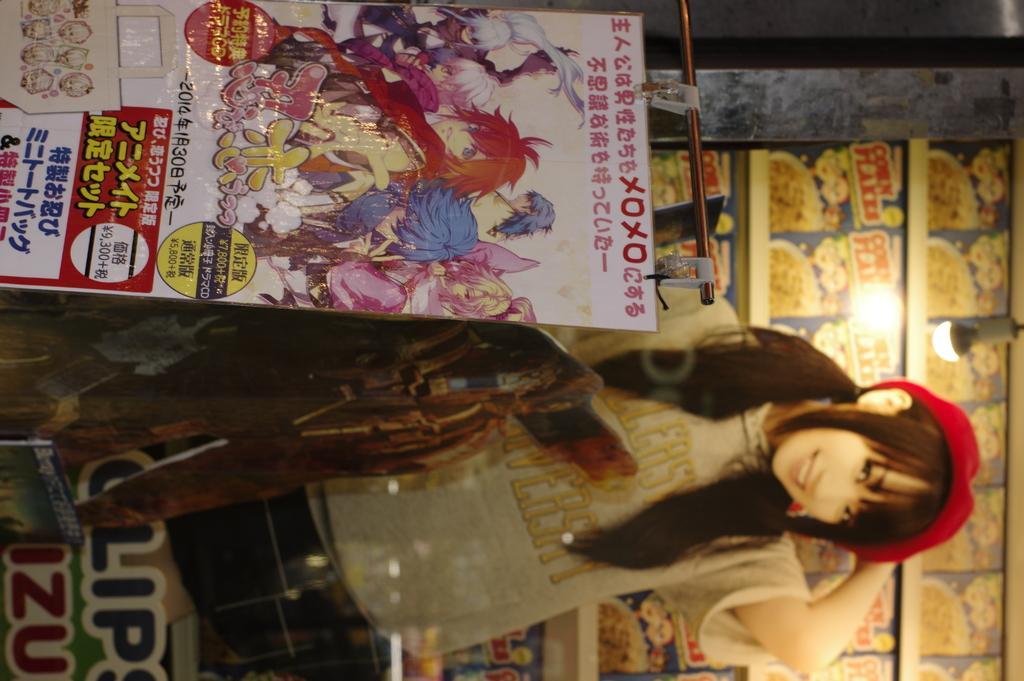Could you give a brief overview of what you see in this image? In this image there is a poster on that there are cartoon pictures and some text, beside that there is a poster of a girl, on above that there is a light in the background there is shelf in that shelf there are packets. 